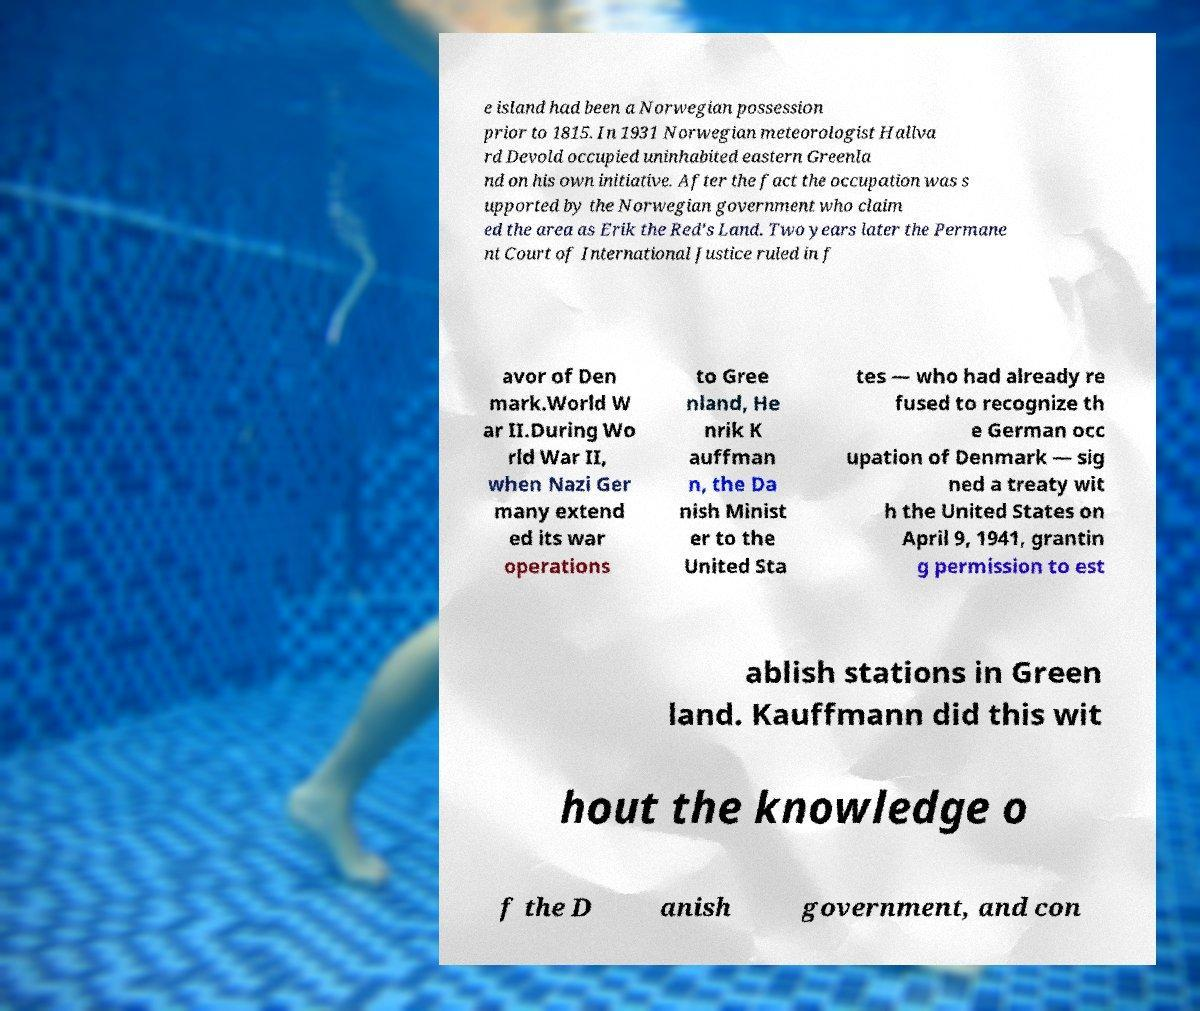Please read and relay the text visible in this image. What does it say? e island had been a Norwegian possession prior to 1815. In 1931 Norwegian meteorologist Hallva rd Devold occupied uninhabited eastern Greenla nd on his own initiative. After the fact the occupation was s upported by the Norwegian government who claim ed the area as Erik the Red's Land. Two years later the Permane nt Court of International Justice ruled in f avor of Den mark.World W ar II.During Wo rld War II, when Nazi Ger many extend ed its war operations to Gree nland, He nrik K auffman n, the Da nish Minist er to the United Sta tes — who had already re fused to recognize th e German occ upation of Denmark — sig ned a treaty wit h the United States on April 9, 1941, grantin g permission to est ablish stations in Green land. Kauffmann did this wit hout the knowledge o f the D anish government, and con 